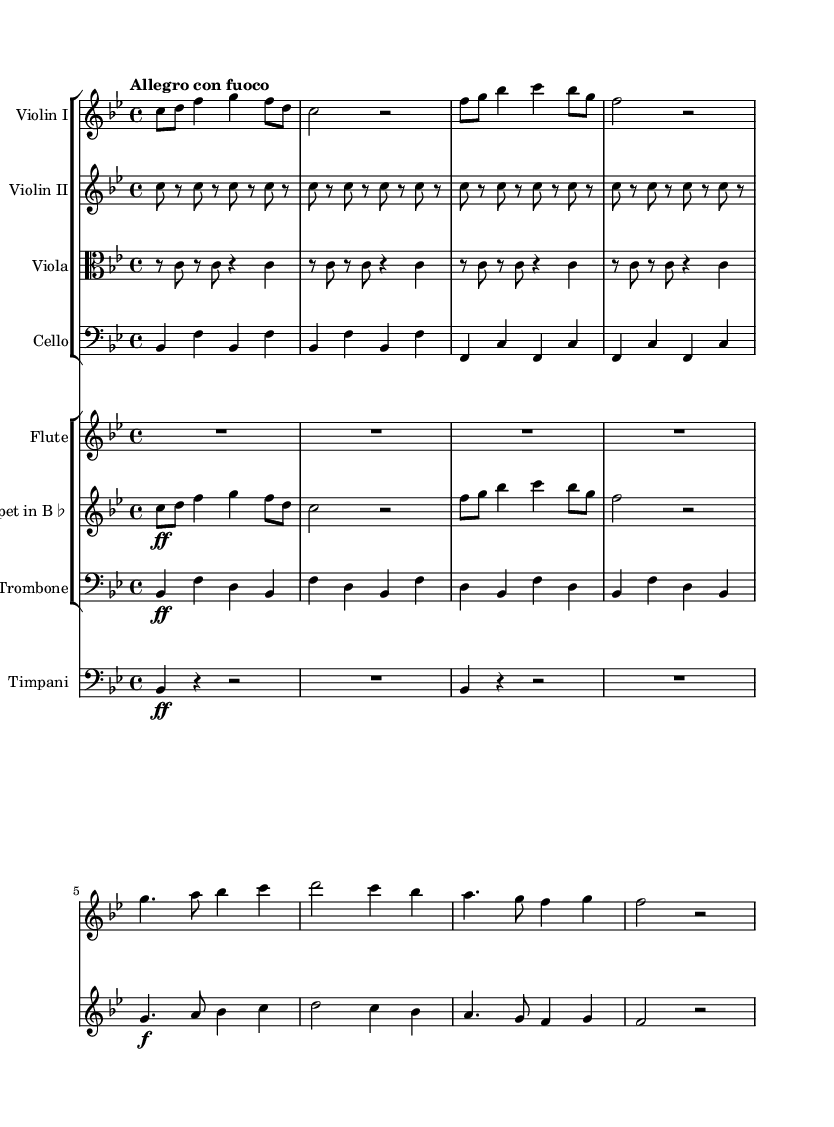What is the key signature of this music? The key signature indicates that there are two flats, which correspond to B flat major. The B flat and E flat notes are indicated at the beginning of each staff line.
Answer: B flat major What is the time signature of this composition? The time signature is 4/4, meaning there are four beats in each measure and the quarter note gets one beat. This can be seen at the start of the music after the key signature.
Answer: 4/4 What is the tempo marking given for this piece? The tempo marking at the beginning of the music is "Allegro con fuoco". "Allegro" indicates that it's to be played fast, while "con fuoco" suggests a fiery character.
Answer: Allegro con fuoco How many total instruments are included in this symphony? Counting the distinct staves present in the score, we can see Violin I, Violin II, Viola, Cello, Flute, Trumpet, Trombone, and Timpani, which totals to eight instruments.
Answer: Eight What is the first note played by Violin I? The first note is C, which is indicated at the beginning of the Violin I staff. It can be visually determined by looking at the first note in the sequence.
Answer: C Which instrument has the melodic line starting on G? The Flute has the melodic line that begins on G. This can be confirmed by checking the first note of the flute line in the score.
Answer: Flute Identify the dynamics indicated for the Trombone part. The dynamics indicated for the Trombone part begin with a fortissimo (ff), shown by the notation at the start of the Trombone line. This indicates the section should be played very loudly.
Answer: Fortissimo 